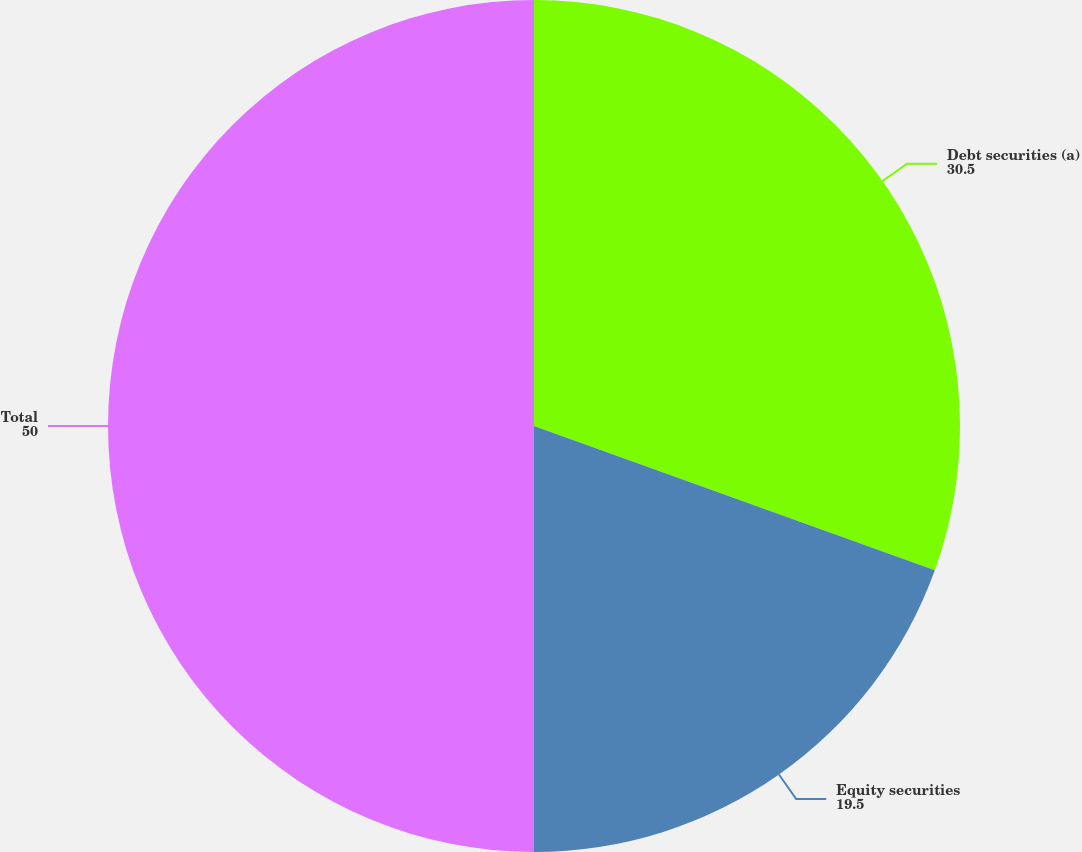<chart> <loc_0><loc_0><loc_500><loc_500><pie_chart><fcel>Debt securities (a)<fcel>Equity securities<fcel>Total<nl><fcel>30.5%<fcel>19.5%<fcel>50.0%<nl></chart> 